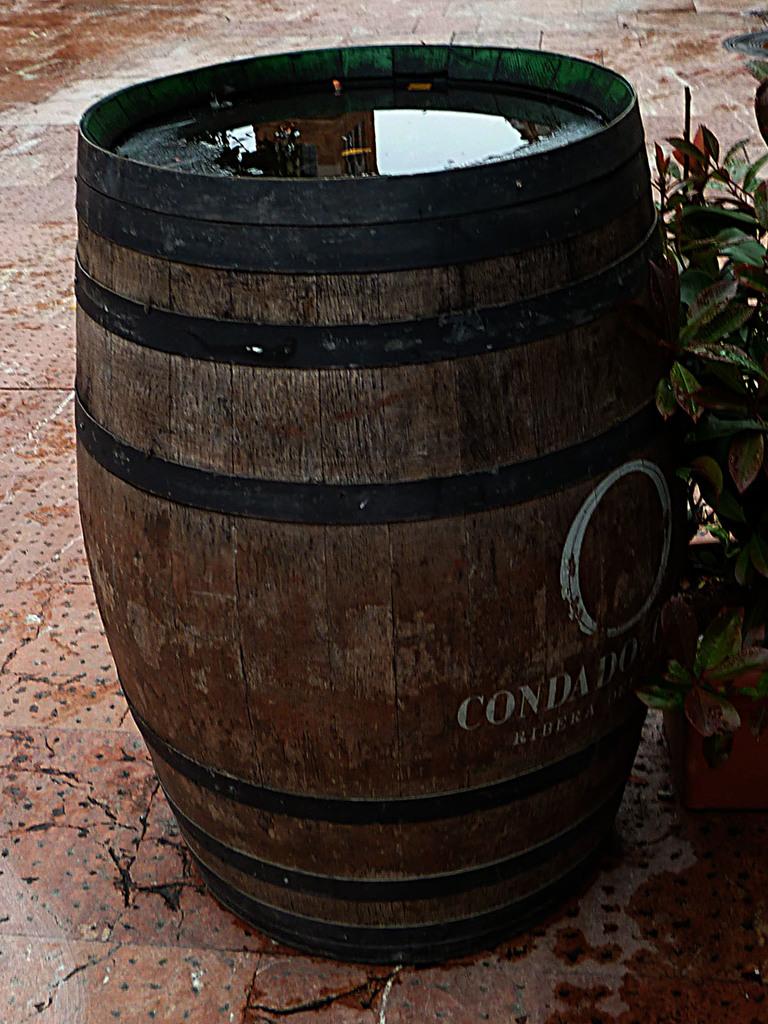What does the barrel say?
Give a very brief answer. Condado. What name is on the barrel?
Your answer should be compact. Condado. 